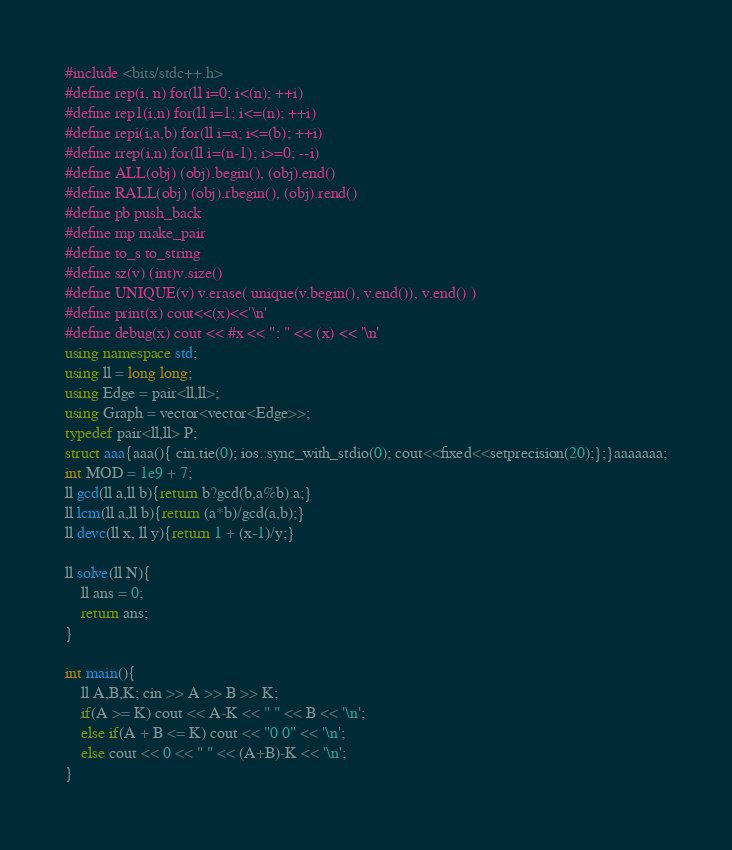<code> <loc_0><loc_0><loc_500><loc_500><_C++_>#include <bits/stdc++.h>
#define rep(i, n) for(ll i=0; i<(n); ++i)
#define rep1(i,n) for(ll i=1; i<=(n); ++i)
#define repi(i,a,b) for(ll i=a; i<=(b); ++i)
#define rrep(i,n) for(ll i=(n-1); i>=0; --i)
#define ALL(obj) (obj).begin(), (obj).end()
#define RALL(obj) (obj).rbegin(), (obj).rend()
#define pb push_back
#define mp make_pair
#define to_s to_string
#define sz(v) (int)v.size()
#define UNIQUE(v) v.erase( unique(v.begin(), v.end()), v.end() )
#define print(x) cout<<(x)<<'\n'
#define debug(x) cout << #x << ": " << (x) << '\n'
using namespace std;
using ll = long long;
using Edge = pair<ll,ll>;
using Graph = vector<vector<Edge>>;
typedef pair<ll,ll> P;
struct aaa{aaa(){ cin.tie(0); ios::sync_with_stdio(0); cout<<fixed<<setprecision(20);};}aaaaaaa;
int MOD = 1e9 + 7;
ll gcd(ll a,ll b){return b?gcd(b,a%b):a;}
ll lcm(ll a,ll b){return (a*b)/gcd(a,b);}
ll devc(ll x, ll y){return 1 + (x-1)/y;}
 
ll solve(ll N){
    ll ans = 0;
    return ans;
}
 
int main(){
    ll A,B,K; cin >> A >> B >> K;
    if(A >= K) cout << A-K << " " << B << '\n';
    else if(A + B <= K) cout << "0 0" << '\n';
    else cout << 0 << " " << (A+B)-K << '\n';
}</code> 